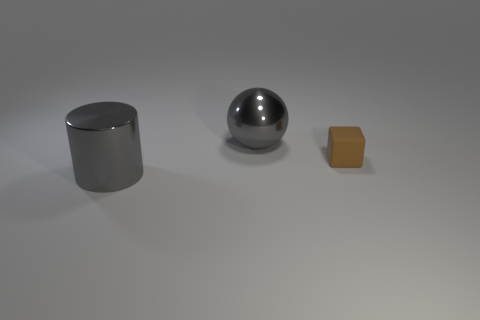Subtract all cylinders. How many objects are left? 2 Add 2 big spheres. How many objects exist? 5 Subtract all large gray shiny objects. Subtract all big spheres. How many objects are left? 0 Add 2 cubes. How many cubes are left? 3 Add 3 big gray shiny cylinders. How many big gray shiny cylinders exist? 4 Subtract 0 yellow cylinders. How many objects are left? 3 Subtract 1 cylinders. How many cylinders are left? 0 Subtract all red cubes. Subtract all purple cylinders. How many cubes are left? 1 